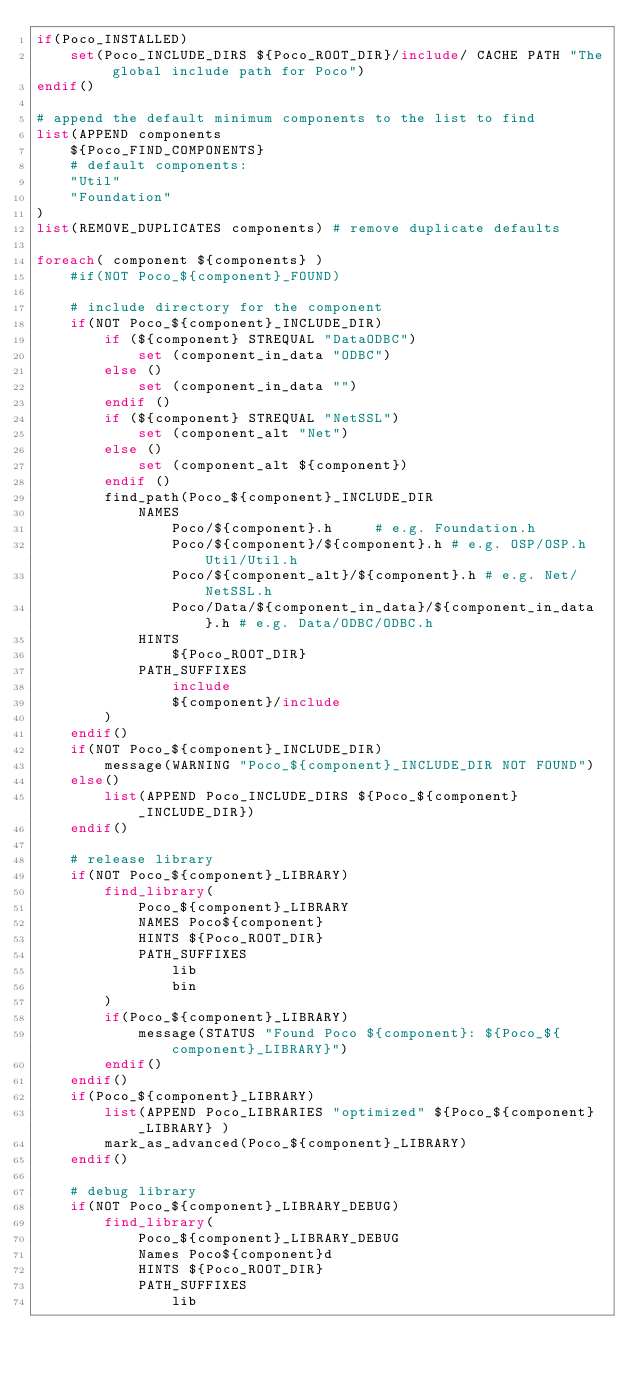<code> <loc_0><loc_0><loc_500><loc_500><_CMake_>if(Poco_INSTALLED)
    set(Poco_INCLUDE_DIRS ${Poco_ROOT_DIR}/include/ CACHE PATH "The global include path for Poco")
endif()

# append the default minimum components to the list to find
list(APPEND components
    ${Poco_FIND_COMPONENTS}
    # default components:
    "Util"
    "Foundation"
)
list(REMOVE_DUPLICATES components) # remove duplicate defaults

foreach( component ${components} )
    #if(NOT Poco_${component}_FOUND)

    # include directory for the component
    if(NOT Poco_${component}_INCLUDE_DIR)
        if (${component} STREQUAL "DataODBC")
            set (component_in_data "ODBC")
        else ()
            set (component_in_data "")
        endif ()
        if (${component} STREQUAL "NetSSL")
            set (component_alt "Net")
        else ()
            set (component_alt ${component})
        endif ()
        find_path(Poco_${component}_INCLUDE_DIR
            NAMES
                Poco/${component}.h     # e.g. Foundation.h
                Poco/${component}/${component}.h # e.g. OSP/OSP.h Util/Util.h
                Poco/${component_alt}/${component}.h # e.g. Net/NetSSL.h
                Poco/Data/${component_in_data}/${component_in_data}.h # e.g. Data/ODBC/ODBC.h
            HINTS
                ${Poco_ROOT_DIR}
            PATH_SUFFIXES
                include
                ${component}/include
        )
    endif()
    if(NOT Poco_${component}_INCLUDE_DIR)
        message(WARNING "Poco_${component}_INCLUDE_DIR NOT FOUND")
    else()
        list(APPEND Poco_INCLUDE_DIRS ${Poco_${component}_INCLUDE_DIR})
    endif()

    # release library
    if(NOT Poco_${component}_LIBRARY)
        find_library(
            Poco_${component}_LIBRARY
            NAMES Poco${component}
            HINTS ${Poco_ROOT_DIR}
            PATH_SUFFIXES
                lib
                bin
        )
        if(Poco_${component}_LIBRARY)
            message(STATUS "Found Poco ${component}: ${Poco_${component}_LIBRARY}")
        endif()
    endif()
    if(Poco_${component}_LIBRARY)
        list(APPEND Poco_LIBRARIES "optimized" ${Poco_${component}_LIBRARY} )
        mark_as_advanced(Poco_${component}_LIBRARY)
    endif()

    # debug library
    if(NOT Poco_${component}_LIBRARY_DEBUG)
        find_library(
            Poco_${component}_LIBRARY_DEBUG
            Names Poco${component}d
            HINTS ${Poco_ROOT_DIR}
            PATH_SUFFIXES
                lib</code> 